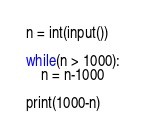<code> <loc_0><loc_0><loc_500><loc_500><_Python_>n = int(input())

while(n > 1000):
    n = n-1000

print(1000-n)</code> 